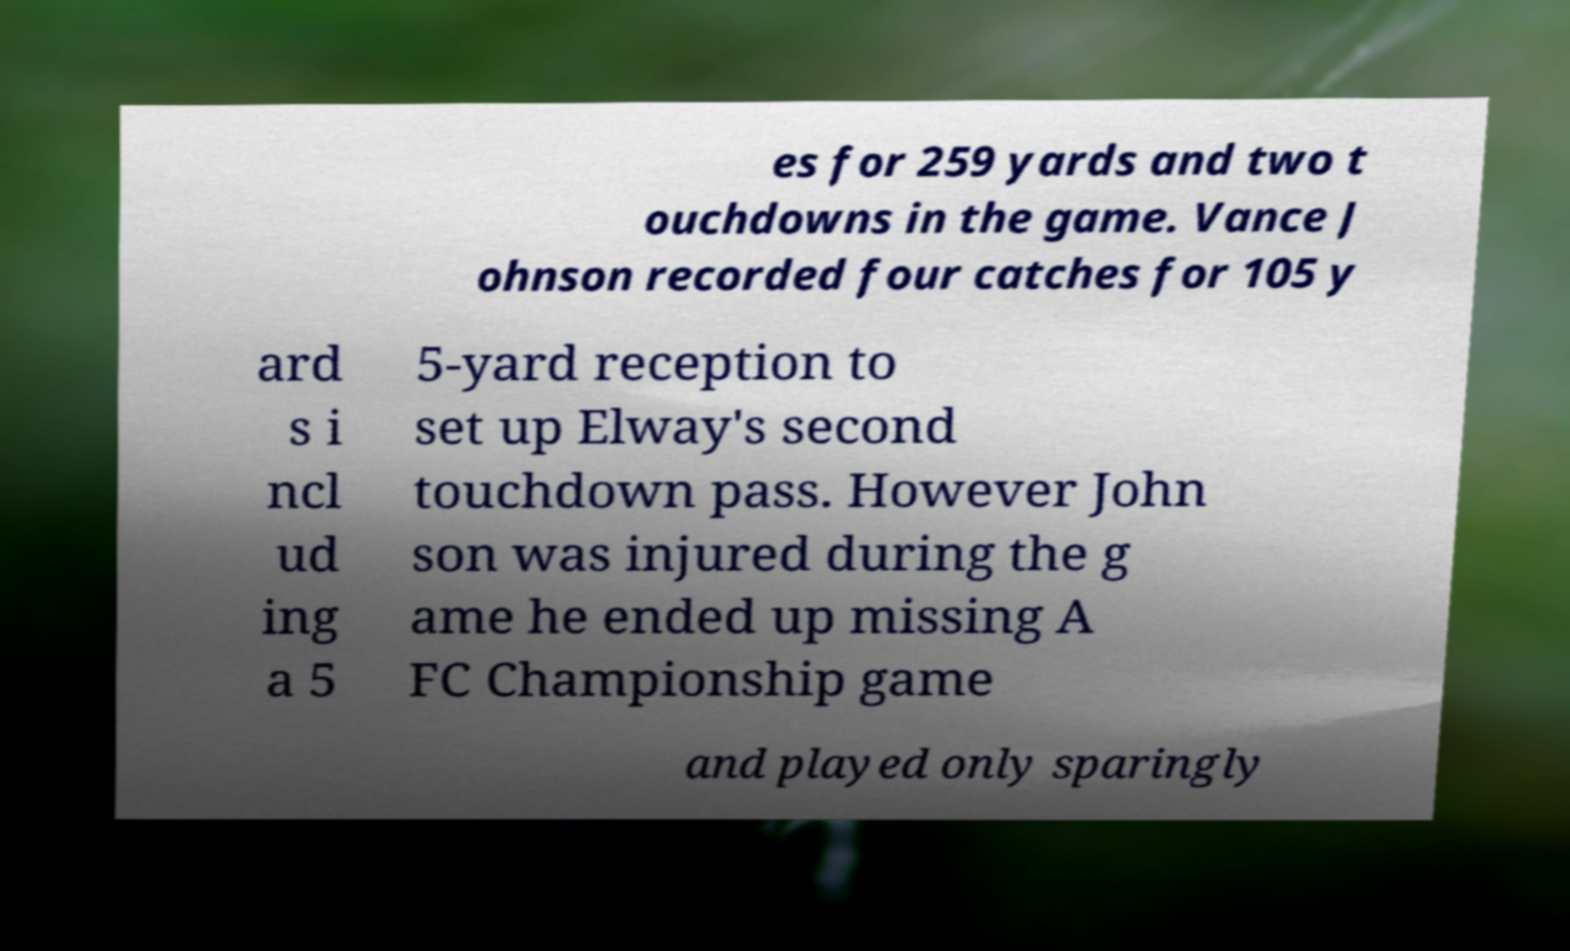What messages or text are displayed in this image? I need them in a readable, typed format. es for 259 yards and two t ouchdowns in the game. Vance J ohnson recorded four catches for 105 y ard s i ncl ud ing a 5 5-yard reception to set up Elway's second touchdown pass. However John son was injured during the g ame he ended up missing A FC Championship game and played only sparingly 